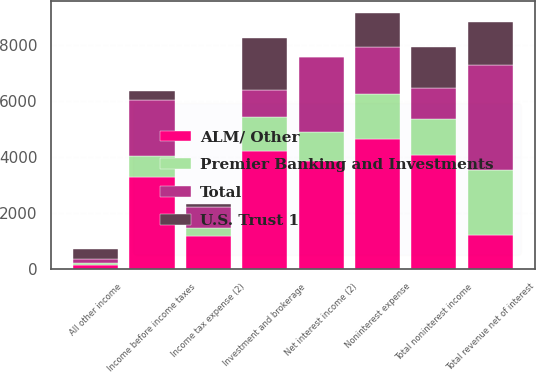Convert chart to OTSL. <chart><loc_0><loc_0><loc_500><loc_500><stacked_bar_chart><ecel><fcel>Net interest income (2)<fcel>Investment and brokerage<fcel>All other income<fcel>Total noninterest income<fcel>Total revenue net of interest<fcel>Noninterest expense<fcel>Income before income taxes<fcel>Income tax expense (2)<nl><fcel>ALM/ Other<fcel>3857<fcel>4210<fcel>144<fcel>4066<fcel>1226<fcel>4635<fcel>3274<fcel>1179<nl><fcel>Premier Banking and Investments<fcel>1036<fcel>1226<fcel>57<fcel>1283<fcel>2319<fcel>1592<fcel>741<fcel>274<nl><fcel>U.S. Trust 1<fcel>15<fcel>1857<fcel>366<fcel>1491<fcel>1506<fcel>1196<fcel>310<fcel>114<nl><fcel>Total<fcel>2655<fcel>950<fcel>146<fcel>1096<fcel>3751<fcel>1700<fcel>2024<fcel>749<nl></chart> 